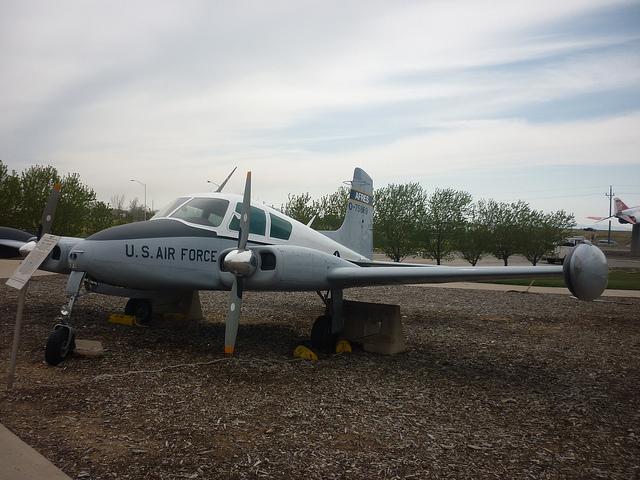Which branch of the service was this plane used in?
Answer briefly. Air force. Where is the plane going?
Answer briefly. Nowhere. Is this an US plane?
Be succinct. Yes. What country is this jet fighter from?
Write a very short answer. Usa. Who owned this plane?
Answer briefly. Us air force. Is this plane going to depart?
Keep it brief. No. What color is the airplane?
Keep it brief. White. IS it on the runway?
Be succinct. No. Is this a runway?
Be succinct. No. 